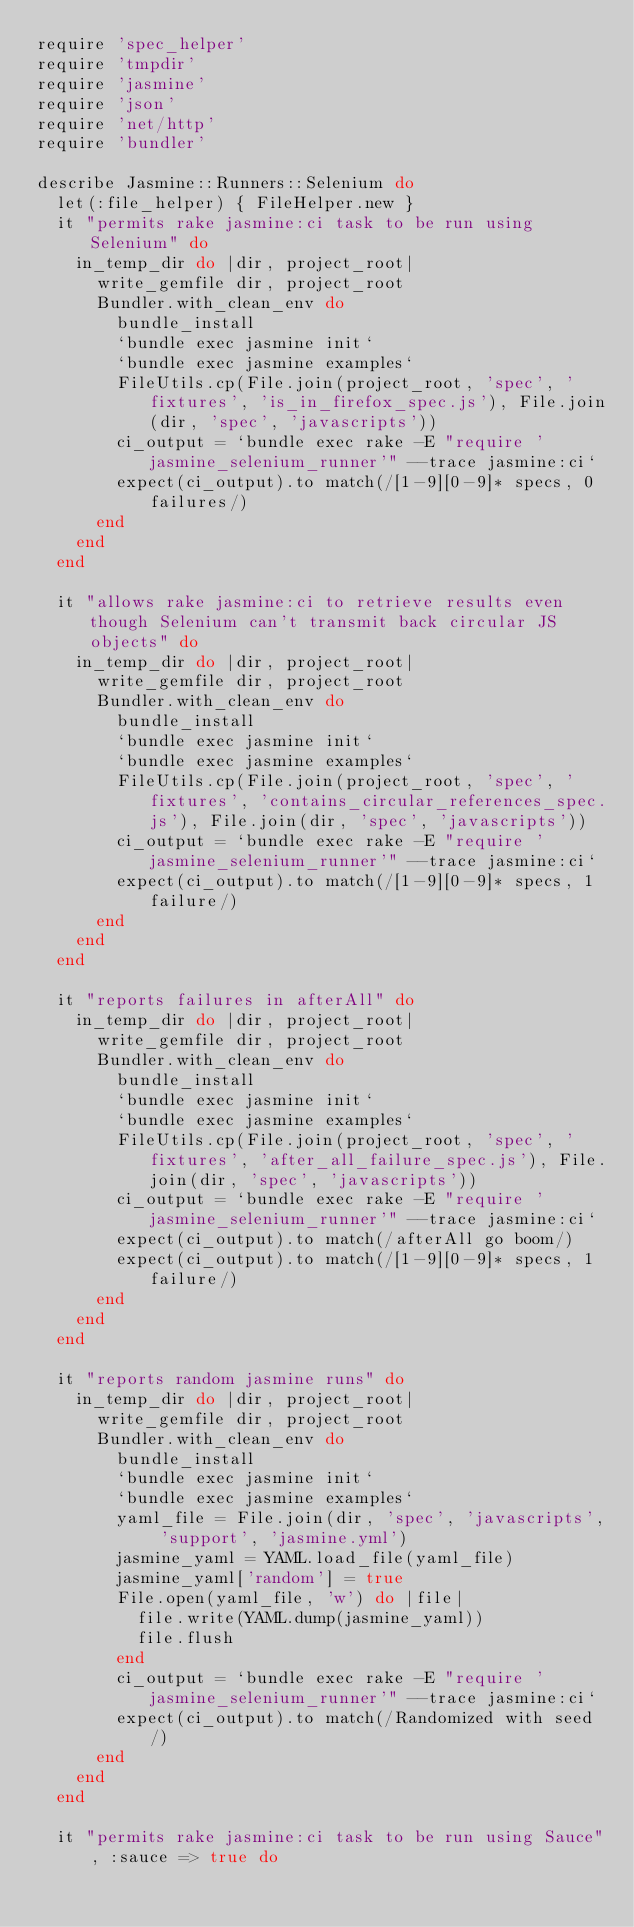Convert code to text. <code><loc_0><loc_0><loc_500><loc_500><_Ruby_>require 'spec_helper'
require 'tmpdir'
require 'jasmine'
require 'json'
require 'net/http'
require 'bundler'

describe Jasmine::Runners::Selenium do
  let(:file_helper) { FileHelper.new }
  it "permits rake jasmine:ci task to be run using Selenium" do
    in_temp_dir do |dir, project_root|
      write_gemfile dir, project_root
      Bundler.with_clean_env do
        bundle_install
        `bundle exec jasmine init`
        `bundle exec jasmine examples`
        FileUtils.cp(File.join(project_root, 'spec', 'fixtures', 'is_in_firefox_spec.js'), File.join(dir, 'spec', 'javascripts'))
        ci_output = `bundle exec rake -E "require 'jasmine_selenium_runner'" --trace jasmine:ci`
        expect(ci_output).to match(/[1-9][0-9]* specs, 0 failures/)
      end
    end
  end

  it "allows rake jasmine:ci to retrieve results even though Selenium can't transmit back circular JS objects" do
    in_temp_dir do |dir, project_root|
      write_gemfile dir, project_root
      Bundler.with_clean_env do
        bundle_install
        `bundle exec jasmine init`
        `bundle exec jasmine examples`
        FileUtils.cp(File.join(project_root, 'spec', 'fixtures', 'contains_circular_references_spec.js'), File.join(dir, 'spec', 'javascripts'))
        ci_output = `bundle exec rake -E "require 'jasmine_selenium_runner'" --trace jasmine:ci`
        expect(ci_output).to match(/[1-9][0-9]* specs, 1 failure/)
      end
    end
  end

  it "reports failures in afterAll" do
    in_temp_dir do |dir, project_root|
      write_gemfile dir, project_root
      Bundler.with_clean_env do
        bundle_install
        `bundle exec jasmine init`
        `bundle exec jasmine examples`
        FileUtils.cp(File.join(project_root, 'spec', 'fixtures', 'after_all_failure_spec.js'), File.join(dir, 'spec', 'javascripts'))
        ci_output = `bundle exec rake -E "require 'jasmine_selenium_runner'" --trace jasmine:ci`
        expect(ci_output).to match(/afterAll go boom/)
        expect(ci_output).to match(/[1-9][0-9]* specs, 1 failure/)
      end
    end
  end

  it "reports random jasmine runs" do
    in_temp_dir do |dir, project_root|
      write_gemfile dir, project_root
      Bundler.with_clean_env do
        bundle_install
        `bundle exec jasmine init`
        `bundle exec jasmine examples`
        yaml_file = File.join(dir, 'spec', 'javascripts', 'support', 'jasmine.yml')
        jasmine_yaml = YAML.load_file(yaml_file)
        jasmine_yaml['random'] = true
        File.open(yaml_file, 'w') do |file|
          file.write(YAML.dump(jasmine_yaml))
          file.flush
        end
        ci_output = `bundle exec rake -E "require 'jasmine_selenium_runner'" --trace jasmine:ci`
        expect(ci_output).to match(/Randomized with seed/)
      end
    end
  end

  it "permits rake jasmine:ci task to be run using Sauce", :sauce => true do</code> 